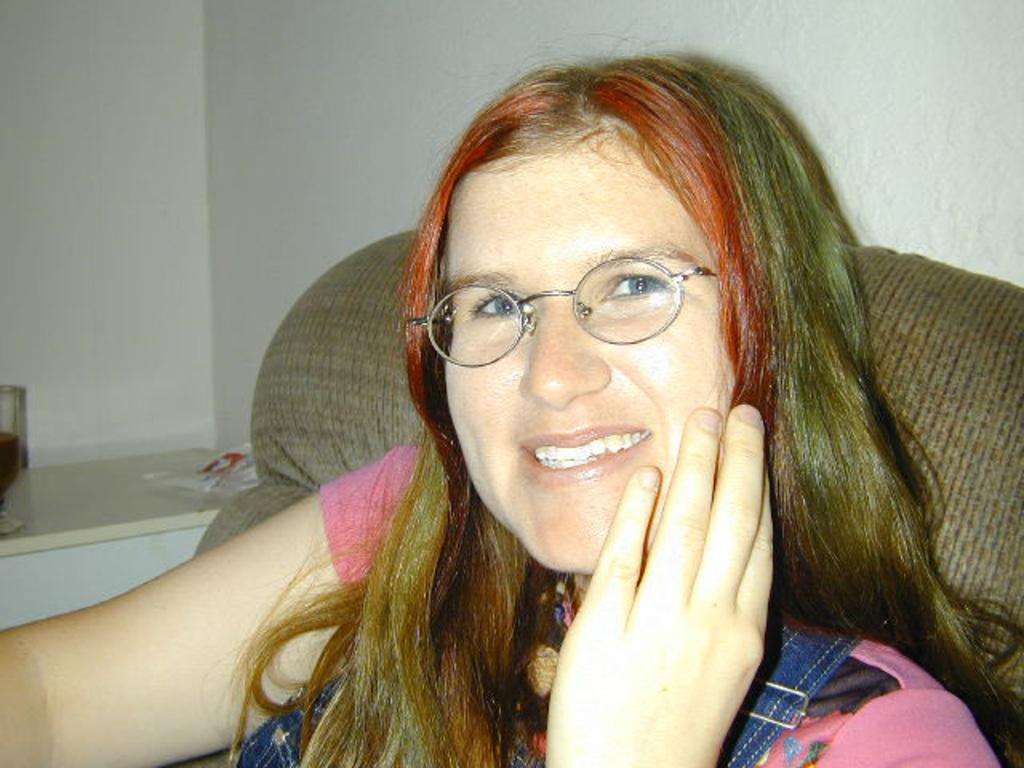Who is the main subject in the image? There is a woman in the image. What is the woman wearing on her face? The woman is wearing glasses. What color is the dress the woman is wearing? The woman is wearing a pink dress. Where is the woman sitting in the image? The woman is sitting on a sofa. What can be seen on the left side of the image? There is a glass on the left side of the image. What type of boot can be seen hanging from the ceiling in the image? There is no boot present in the image; it only features a woman sitting on a sofa, wearing glasses and a pink dress, and a glass on the left side. 